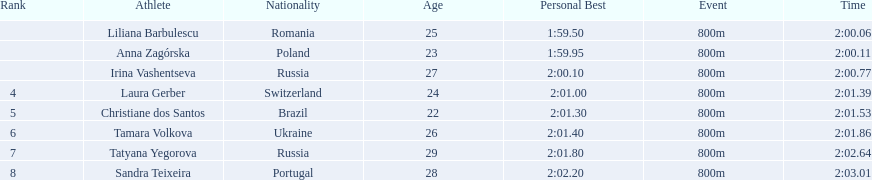What are the names of the competitors? Liliana Barbulescu, Anna Zagórska, Irina Vashentseva, Laura Gerber, Christiane dos Santos, Tamara Volkova, Tatyana Yegorova, Sandra Teixeira. Which finalist finished the fastest? Liliana Barbulescu. 